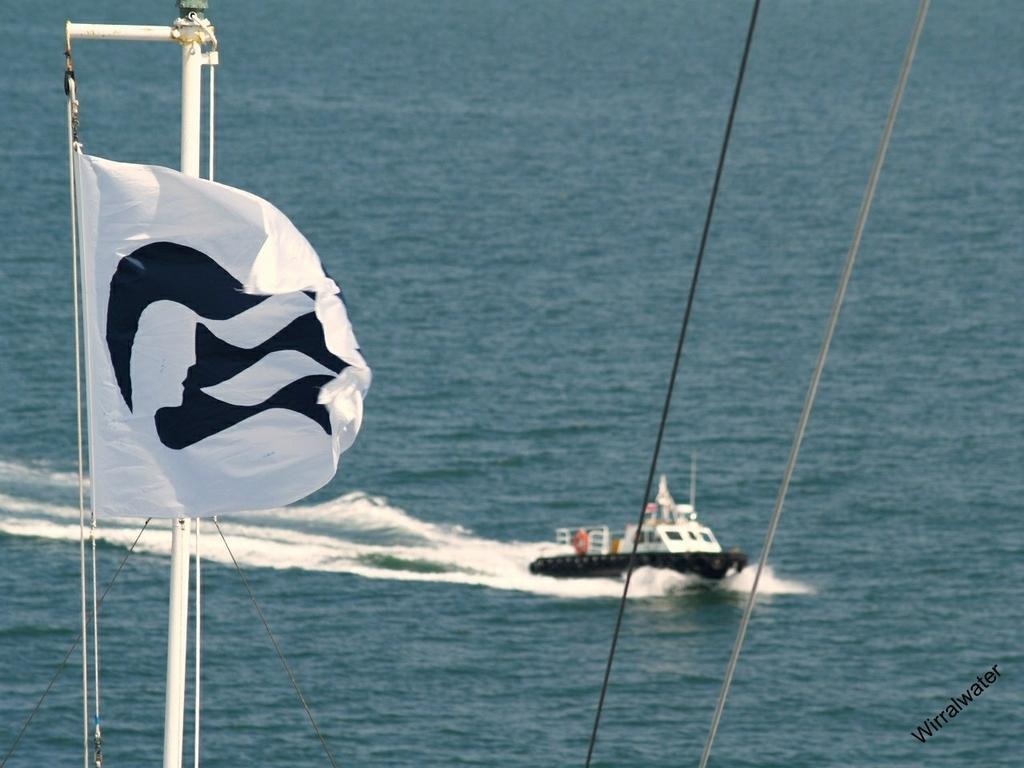What is present in the image that indicates the presence of water? There is water visible in the image. What type of vehicle is in the image? There is a boat in the image. What color is the flag in the image? There is a white flag in the image. What object is made of white iron in the image? There is a white iron pole in the image. Where can the goat be found in the image? There is no goat present in the image. What type of honey is being produced by the boat in the image? There is no honey production in the image; it features a boat on water. 